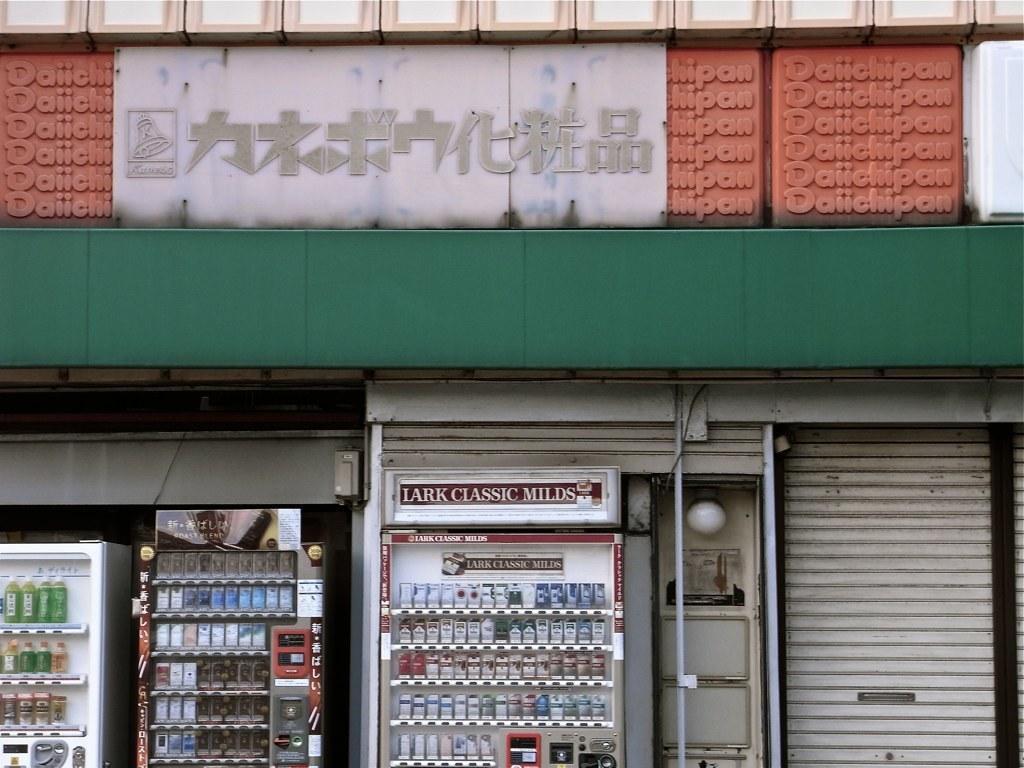In one or two sentences, can you explain what this image depicts? The picture consists of a store. At the bottom there are refrigerators filled with drinks. In the center there is a wall painted in green color. At the top there is a hoarding, with some text on it. 